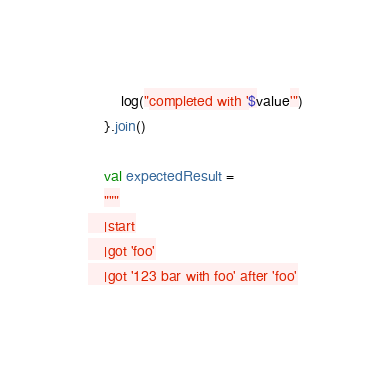<code> <loc_0><loc_0><loc_500><loc_500><_Kotlin_>        log("completed with '$value'")
    }.join()

    val expectedResult =
    """
    |start
    |got 'foo'
    |got '123 bar with foo' after 'foo'</code> 